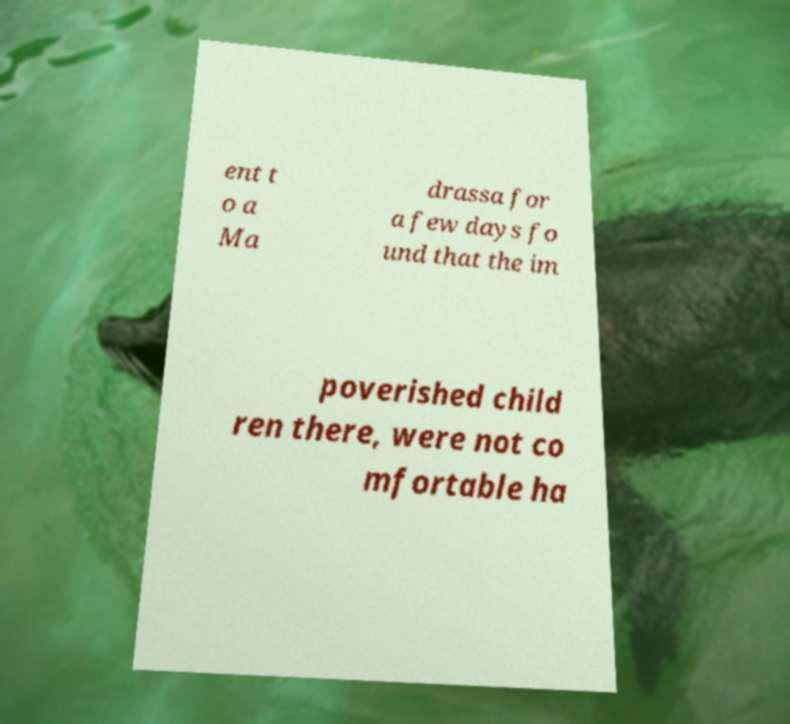There's text embedded in this image that I need extracted. Can you transcribe it verbatim? ent t o a Ma drassa for a few days fo und that the im poverished child ren there, were not co mfortable ha 